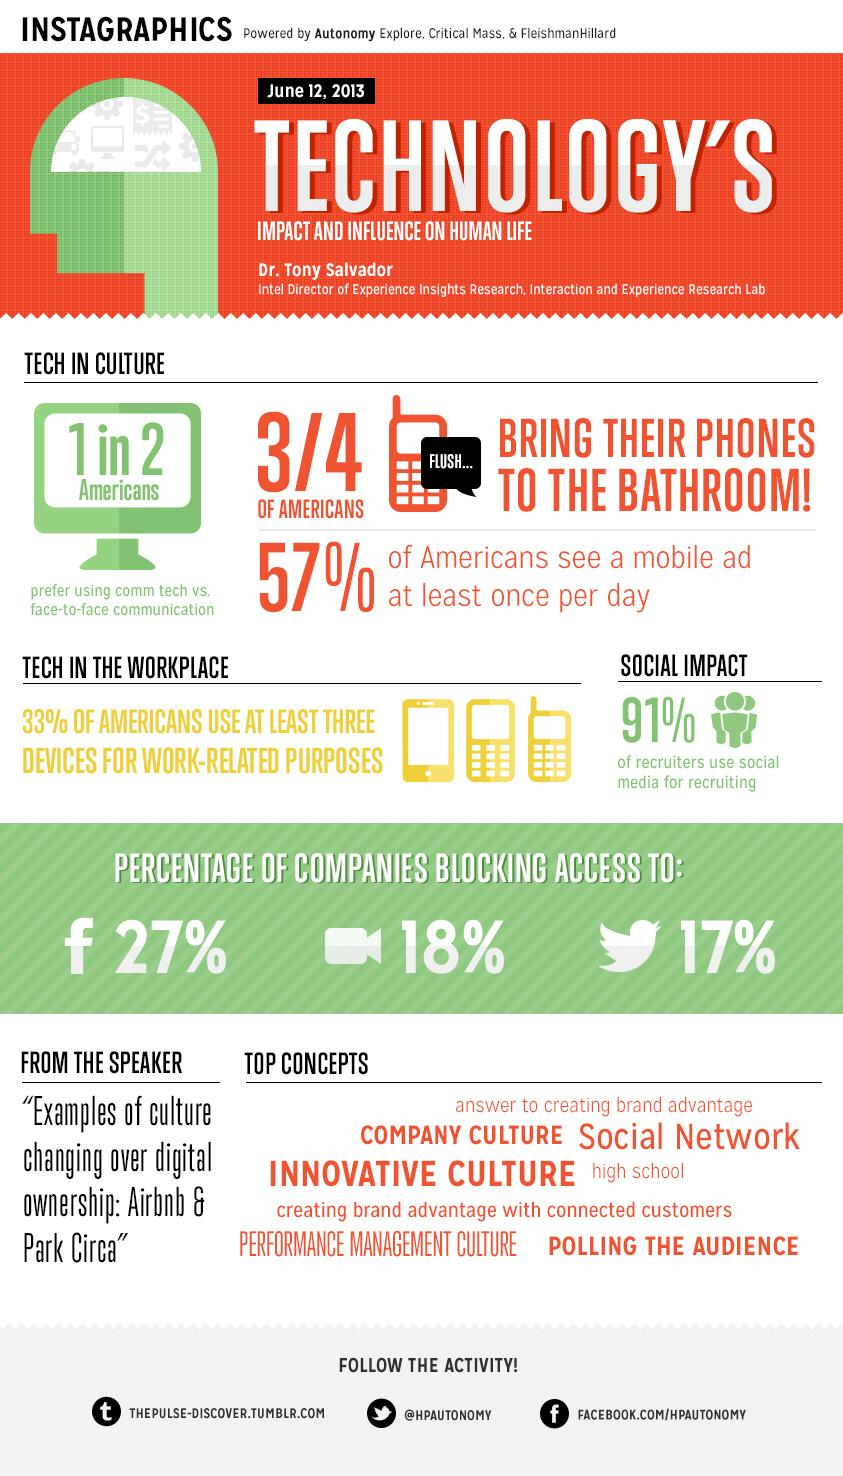Specify some key components in this picture. The Twitter handle given is "@HPAUTONOMY. According to a recent survey, 17% of companies are blocking access to Twitter. According to a recent survey, 43% of Americans do not view a mobile ad at least once per day. Facebook is the social network that is most commonly blocked by companies. According to a recent survey, approximately 25% of Americans do not bring their phones to the bathroom. 